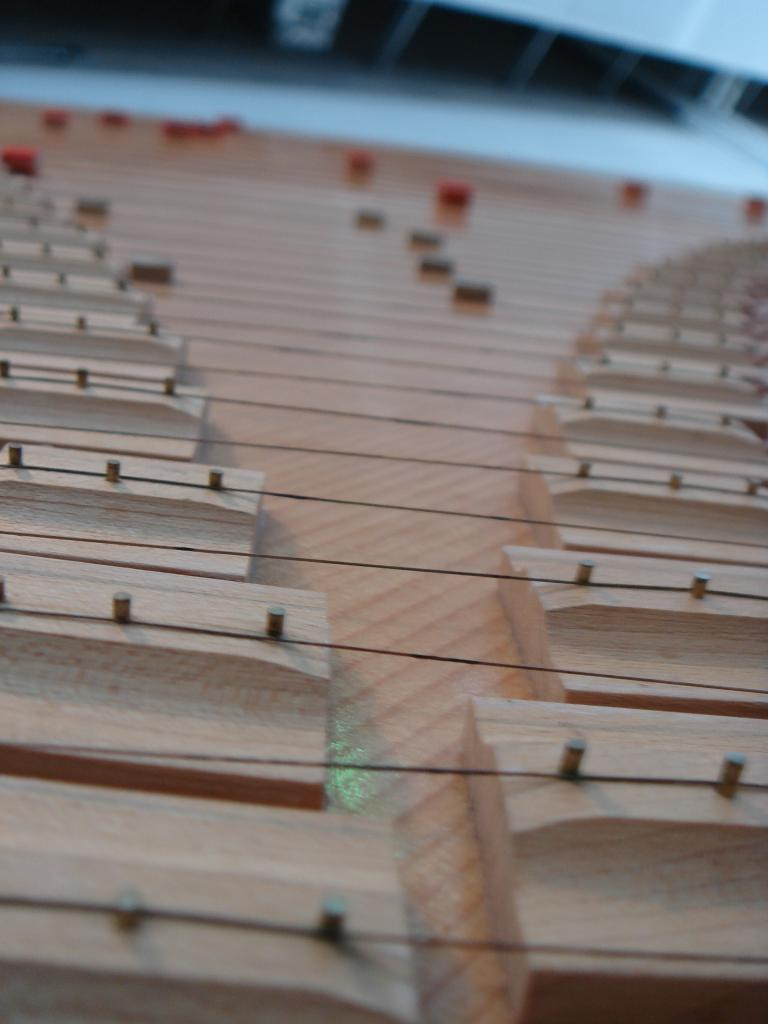What type of material is the main object in the image made of? The main object in the image is made of wood. What color is the wooden object? The wooden object is cream in color. Are there any additional features on the wooden object? Yes, there are strings attached to the wooden object. How would you describe the background of the image? The background of the image is blurry. What colors can be seen in the background? The background contains red and black colored objects. Can you tell me how many friends the wooden object has in the image? There are no friends depicted in the image; it only features the wooden object and the background. Does the wooden object sneeze in the image? The wooden object does not have the ability to sneeze, as it is an inanimate object. 